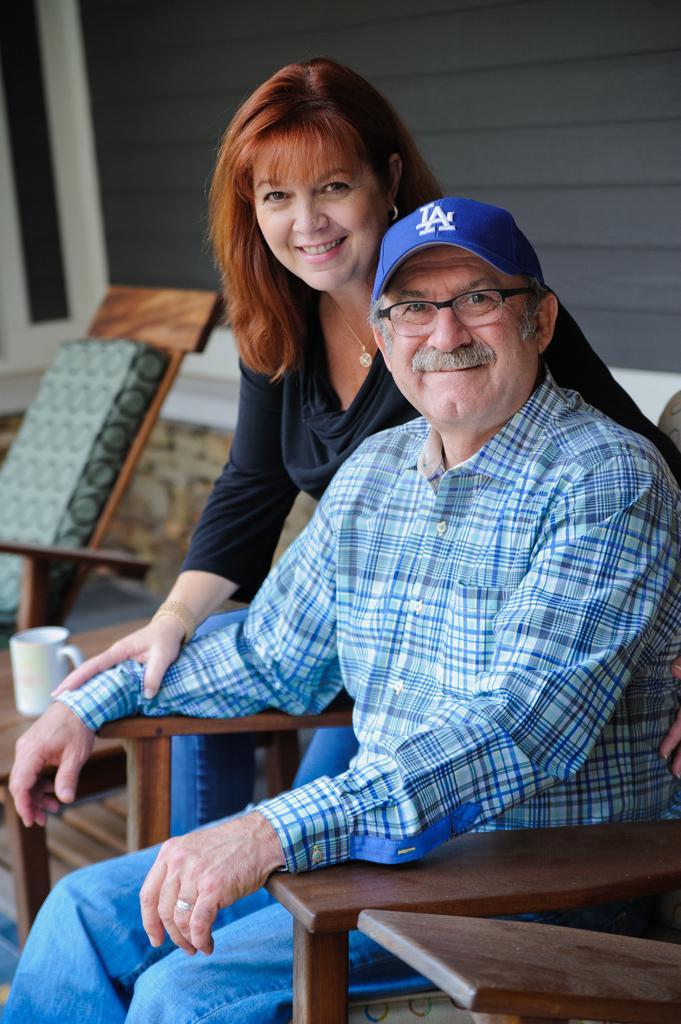Could you give a brief overview of what you see in this image? In the image there are two people both man and woman. Man is sitting on chair and he is also wearing his hat beside woman there is a table. On table there is a coffee cup and background there is a wall which is in black color. 